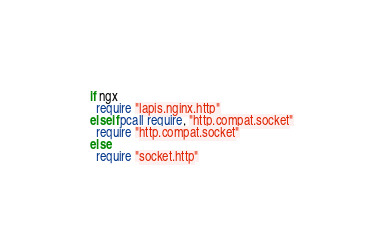<code> <loc_0><loc_0><loc_500><loc_500><_MoonScript_>if ngx
  require "lapis.nginx.http"
elseif pcall require, "http.compat.socket"
  require "http.compat.socket"
else
  require "socket.http"
</code> 